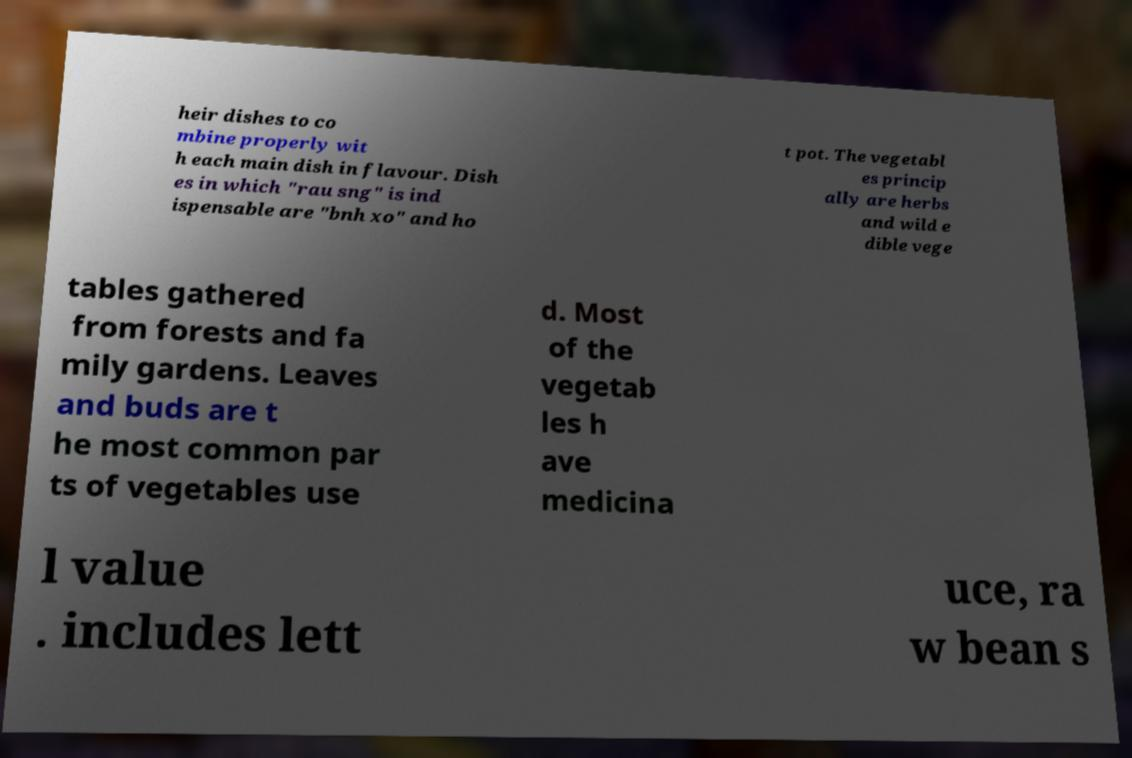For documentation purposes, I need the text within this image transcribed. Could you provide that? heir dishes to co mbine properly wit h each main dish in flavour. Dish es in which "rau sng" is ind ispensable are "bnh xo" and ho t pot. The vegetabl es princip ally are herbs and wild e dible vege tables gathered from forests and fa mily gardens. Leaves and buds are t he most common par ts of vegetables use d. Most of the vegetab les h ave medicina l value . includes lett uce, ra w bean s 